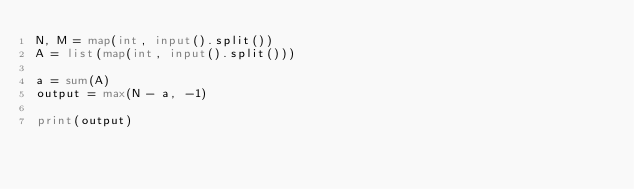Convert code to text. <code><loc_0><loc_0><loc_500><loc_500><_Python_>N, M = map(int, input().split())
A = list(map(int, input().split()))

a = sum(A)
output = max(N - a, -1)

print(output)</code> 